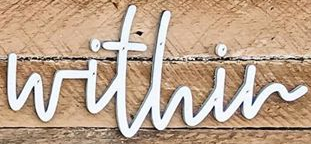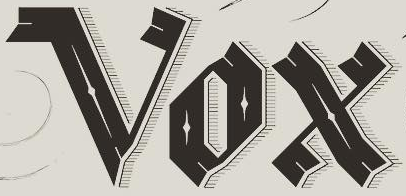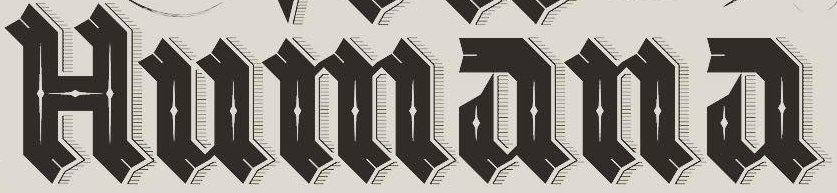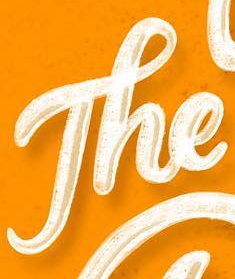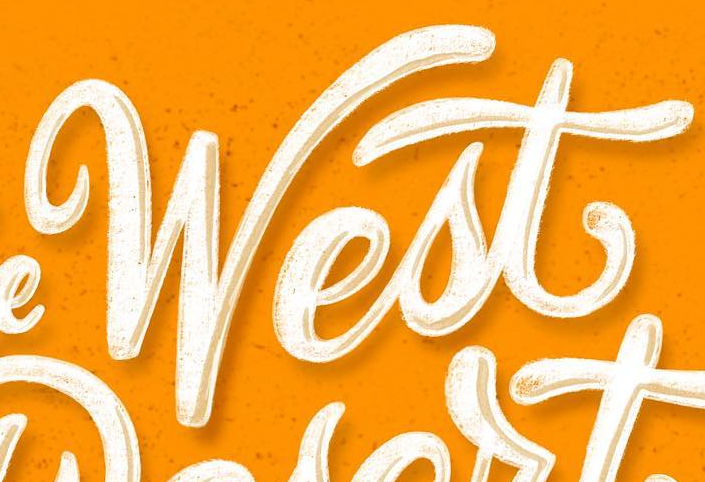Read the text content from these images in order, separated by a semicolon. within; Vox; Humana; The; West 